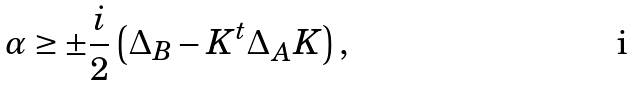<formula> <loc_0><loc_0><loc_500><loc_500>\alpha \geq \pm \frac { i } { 2 } \left ( \Delta _ { B } - K ^ { t } \Delta _ { A } K \right ) ,</formula> 